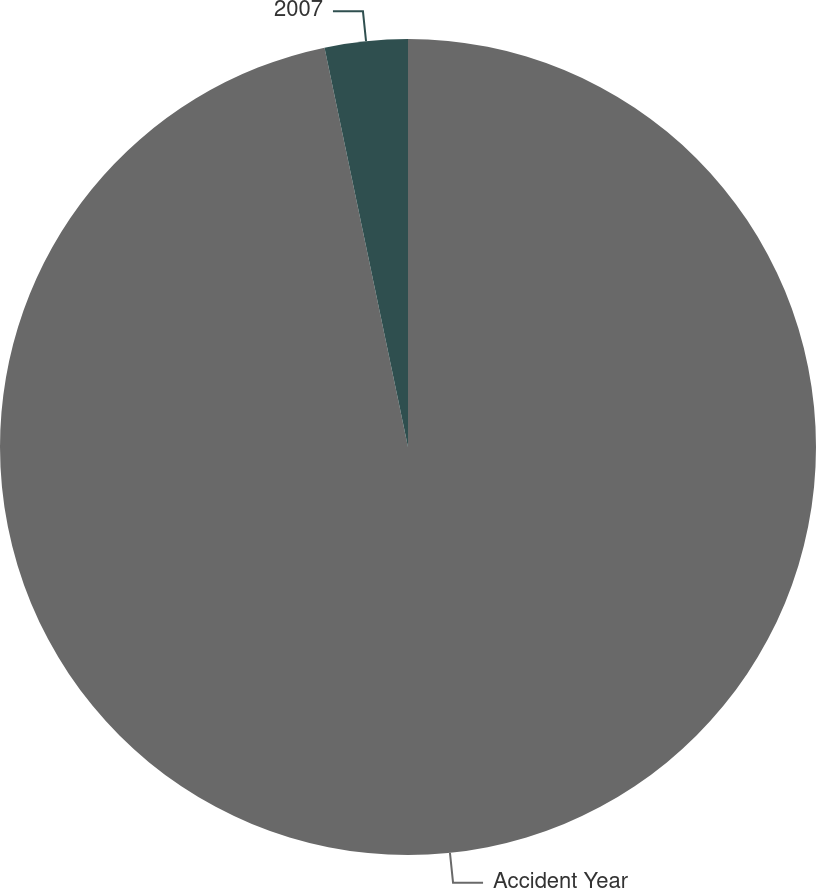<chart> <loc_0><loc_0><loc_500><loc_500><pie_chart><fcel>Accident Year<fcel>2007<nl><fcel>96.72%<fcel>3.28%<nl></chart> 